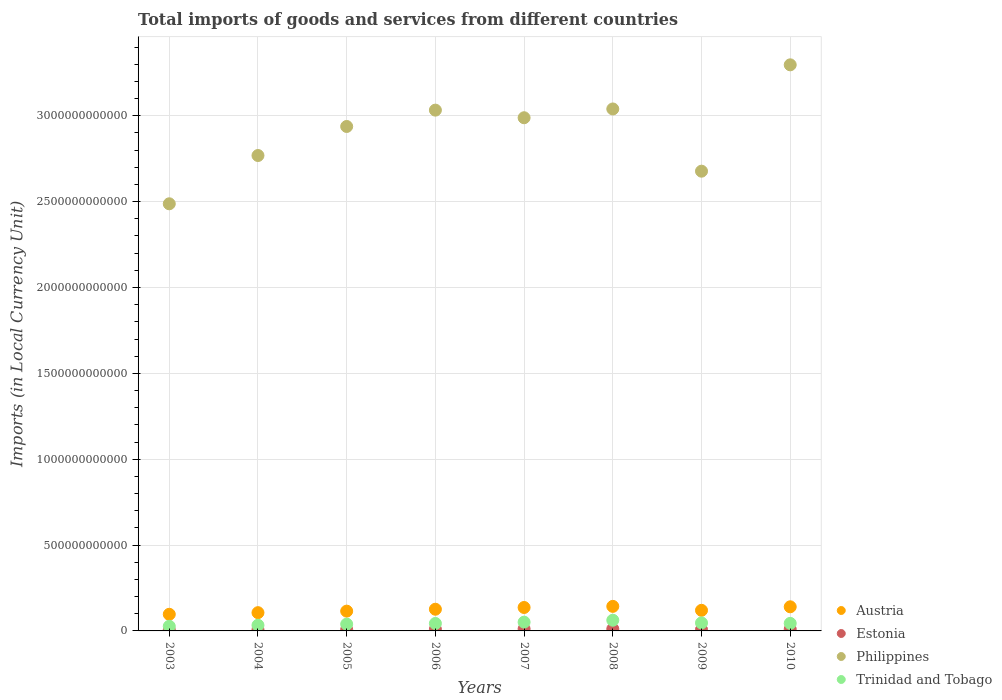How many different coloured dotlines are there?
Your response must be concise. 4. What is the Amount of goods and services imports in Austria in 2005?
Offer a terse response. 1.15e+11. Across all years, what is the maximum Amount of goods and services imports in Estonia?
Give a very brief answer. 1.17e+1. Across all years, what is the minimum Amount of goods and services imports in Philippines?
Your response must be concise. 2.49e+12. What is the total Amount of goods and services imports in Philippines in the graph?
Keep it short and to the point. 2.32e+13. What is the difference between the Amount of goods and services imports in Philippines in 2009 and that in 2010?
Keep it short and to the point. -6.19e+11. What is the difference between the Amount of goods and services imports in Trinidad and Tobago in 2004 and the Amount of goods and services imports in Philippines in 2010?
Give a very brief answer. -3.26e+12. What is the average Amount of goods and services imports in Trinidad and Tobago per year?
Provide a short and direct response. 4.34e+1. In the year 2004, what is the difference between the Amount of goods and services imports in Philippines and Amount of goods and services imports in Trinidad and Tobago?
Offer a terse response. 2.74e+12. What is the ratio of the Amount of goods and services imports in Philippines in 2006 to that in 2009?
Your answer should be very brief. 1.13. Is the Amount of goods and services imports in Estonia in 2004 less than that in 2005?
Make the answer very short. Yes. Is the difference between the Amount of goods and services imports in Philippines in 2003 and 2006 greater than the difference between the Amount of goods and services imports in Trinidad and Tobago in 2003 and 2006?
Offer a terse response. No. What is the difference between the highest and the second highest Amount of goods and services imports in Trinidad and Tobago?
Ensure brevity in your answer.  1.13e+1. What is the difference between the highest and the lowest Amount of goods and services imports in Philippines?
Keep it short and to the point. 8.09e+11. Is the sum of the Amount of goods and services imports in Philippines in 2006 and 2007 greater than the maximum Amount of goods and services imports in Austria across all years?
Give a very brief answer. Yes. How many dotlines are there?
Your answer should be compact. 4. What is the difference between two consecutive major ticks on the Y-axis?
Provide a succinct answer. 5.00e+11. Are the values on the major ticks of Y-axis written in scientific E-notation?
Keep it short and to the point. No. Does the graph contain any zero values?
Offer a very short reply. No. Does the graph contain grids?
Provide a short and direct response. Yes. Where does the legend appear in the graph?
Make the answer very short. Bottom right. How many legend labels are there?
Offer a terse response. 4. What is the title of the graph?
Your answer should be compact. Total imports of goods and services from different countries. Does "San Marino" appear as one of the legend labels in the graph?
Your answer should be very brief. No. What is the label or title of the X-axis?
Your response must be concise. Years. What is the label or title of the Y-axis?
Your response must be concise. Imports (in Local Currency Unit). What is the Imports (in Local Currency Unit) of Austria in 2003?
Your answer should be very brief. 9.68e+1. What is the Imports (in Local Currency Unit) of Estonia in 2003?
Your answer should be very brief. 5.74e+09. What is the Imports (in Local Currency Unit) in Philippines in 2003?
Offer a terse response. 2.49e+12. What is the Imports (in Local Currency Unit) of Trinidad and Tobago in 2003?
Your response must be concise. 2.70e+1. What is the Imports (in Local Currency Unit) of Austria in 2004?
Your answer should be very brief. 1.06e+11. What is the Imports (in Local Currency Unit) in Estonia in 2004?
Your answer should be very brief. 6.74e+09. What is the Imports (in Local Currency Unit) of Philippines in 2004?
Give a very brief answer. 2.77e+12. What is the Imports (in Local Currency Unit) of Trinidad and Tobago in 2004?
Your answer should be very brief. 3.32e+1. What is the Imports (in Local Currency Unit) in Austria in 2005?
Offer a terse response. 1.15e+11. What is the Imports (in Local Currency Unit) of Estonia in 2005?
Provide a short and direct response. 8.00e+09. What is the Imports (in Local Currency Unit) of Philippines in 2005?
Your answer should be very brief. 2.94e+12. What is the Imports (in Local Currency Unit) of Trinidad and Tobago in 2005?
Provide a succinct answer. 3.95e+1. What is the Imports (in Local Currency Unit) in Austria in 2006?
Provide a succinct answer. 1.26e+11. What is the Imports (in Local Currency Unit) in Estonia in 2006?
Keep it short and to the point. 9.96e+09. What is the Imports (in Local Currency Unit) in Philippines in 2006?
Provide a short and direct response. 3.03e+12. What is the Imports (in Local Currency Unit) of Trinidad and Tobago in 2006?
Keep it short and to the point. 4.34e+1. What is the Imports (in Local Currency Unit) of Austria in 2007?
Your response must be concise. 1.36e+11. What is the Imports (in Local Currency Unit) in Estonia in 2007?
Offer a very short reply. 1.17e+1. What is the Imports (in Local Currency Unit) in Philippines in 2007?
Provide a succinct answer. 2.99e+12. What is the Imports (in Local Currency Unit) in Trinidad and Tobago in 2007?
Keep it short and to the point. 5.10e+1. What is the Imports (in Local Currency Unit) in Austria in 2008?
Keep it short and to the point. 1.43e+11. What is the Imports (in Local Currency Unit) in Estonia in 2008?
Ensure brevity in your answer.  1.17e+1. What is the Imports (in Local Currency Unit) in Philippines in 2008?
Give a very brief answer. 3.04e+12. What is the Imports (in Local Currency Unit) of Trinidad and Tobago in 2008?
Give a very brief answer. 6.23e+1. What is the Imports (in Local Currency Unit) in Austria in 2009?
Offer a very short reply. 1.20e+11. What is the Imports (in Local Currency Unit) in Estonia in 2009?
Provide a short and direct response. 7.90e+09. What is the Imports (in Local Currency Unit) in Philippines in 2009?
Provide a short and direct response. 2.68e+12. What is the Imports (in Local Currency Unit) of Trinidad and Tobago in 2009?
Offer a very short reply. 4.66e+1. What is the Imports (in Local Currency Unit) of Austria in 2010?
Offer a very short reply. 1.40e+11. What is the Imports (in Local Currency Unit) of Estonia in 2010?
Keep it short and to the point. 1.01e+1. What is the Imports (in Local Currency Unit) in Philippines in 2010?
Offer a terse response. 3.30e+12. What is the Imports (in Local Currency Unit) of Trinidad and Tobago in 2010?
Provide a succinct answer. 4.39e+1. Across all years, what is the maximum Imports (in Local Currency Unit) in Austria?
Your response must be concise. 1.43e+11. Across all years, what is the maximum Imports (in Local Currency Unit) of Estonia?
Keep it short and to the point. 1.17e+1. Across all years, what is the maximum Imports (in Local Currency Unit) of Philippines?
Your answer should be compact. 3.30e+12. Across all years, what is the maximum Imports (in Local Currency Unit) of Trinidad and Tobago?
Your answer should be compact. 6.23e+1. Across all years, what is the minimum Imports (in Local Currency Unit) of Austria?
Offer a terse response. 9.68e+1. Across all years, what is the minimum Imports (in Local Currency Unit) in Estonia?
Offer a terse response. 5.74e+09. Across all years, what is the minimum Imports (in Local Currency Unit) of Philippines?
Your answer should be very brief. 2.49e+12. Across all years, what is the minimum Imports (in Local Currency Unit) of Trinidad and Tobago?
Your response must be concise. 2.70e+1. What is the total Imports (in Local Currency Unit) of Austria in the graph?
Provide a succinct answer. 9.84e+11. What is the total Imports (in Local Currency Unit) in Estonia in the graph?
Keep it short and to the point. 7.18e+1. What is the total Imports (in Local Currency Unit) of Philippines in the graph?
Your response must be concise. 2.32e+13. What is the total Imports (in Local Currency Unit) in Trinidad and Tobago in the graph?
Provide a short and direct response. 3.47e+11. What is the difference between the Imports (in Local Currency Unit) of Austria in 2003 and that in 2004?
Offer a terse response. -9.49e+09. What is the difference between the Imports (in Local Currency Unit) in Estonia in 2003 and that in 2004?
Offer a very short reply. -9.99e+08. What is the difference between the Imports (in Local Currency Unit) in Philippines in 2003 and that in 2004?
Your answer should be compact. -2.81e+11. What is the difference between the Imports (in Local Currency Unit) in Trinidad and Tobago in 2003 and that in 2004?
Your answer should be compact. -6.20e+09. What is the difference between the Imports (in Local Currency Unit) of Austria in 2003 and that in 2005?
Offer a very short reply. -1.84e+1. What is the difference between the Imports (in Local Currency Unit) in Estonia in 2003 and that in 2005?
Make the answer very short. -2.26e+09. What is the difference between the Imports (in Local Currency Unit) of Philippines in 2003 and that in 2005?
Offer a terse response. -4.50e+11. What is the difference between the Imports (in Local Currency Unit) in Trinidad and Tobago in 2003 and that in 2005?
Offer a very short reply. -1.25e+1. What is the difference between the Imports (in Local Currency Unit) of Austria in 2003 and that in 2006?
Your response must be concise. -2.95e+1. What is the difference between the Imports (in Local Currency Unit) in Estonia in 2003 and that in 2006?
Your answer should be very brief. -4.22e+09. What is the difference between the Imports (in Local Currency Unit) in Philippines in 2003 and that in 2006?
Offer a very short reply. -5.45e+11. What is the difference between the Imports (in Local Currency Unit) of Trinidad and Tobago in 2003 and that in 2006?
Your response must be concise. -1.65e+1. What is the difference between the Imports (in Local Currency Unit) of Austria in 2003 and that in 2007?
Offer a terse response. -3.97e+1. What is the difference between the Imports (in Local Currency Unit) of Estonia in 2003 and that in 2007?
Provide a short and direct response. -5.97e+09. What is the difference between the Imports (in Local Currency Unit) of Philippines in 2003 and that in 2007?
Your response must be concise. -5.01e+11. What is the difference between the Imports (in Local Currency Unit) of Trinidad and Tobago in 2003 and that in 2007?
Ensure brevity in your answer.  -2.41e+1. What is the difference between the Imports (in Local Currency Unit) in Austria in 2003 and that in 2008?
Your response must be concise. -4.61e+1. What is the difference between the Imports (in Local Currency Unit) of Estonia in 2003 and that in 2008?
Ensure brevity in your answer.  -5.94e+09. What is the difference between the Imports (in Local Currency Unit) in Philippines in 2003 and that in 2008?
Your answer should be compact. -5.52e+11. What is the difference between the Imports (in Local Currency Unit) of Trinidad and Tobago in 2003 and that in 2008?
Your response must be concise. -3.53e+1. What is the difference between the Imports (in Local Currency Unit) of Austria in 2003 and that in 2009?
Ensure brevity in your answer.  -2.31e+1. What is the difference between the Imports (in Local Currency Unit) of Estonia in 2003 and that in 2009?
Ensure brevity in your answer.  -2.16e+09. What is the difference between the Imports (in Local Currency Unit) in Philippines in 2003 and that in 2009?
Make the answer very short. -1.90e+11. What is the difference between the Imports (in Local Currency Unit) of Trinidad and Tobago in 2003 and that in 2009?
Keep it short and to the point. -1.96e+1. What is the difference between the Imports (in Local Currency Unit) of Austria in 2003 and that in 2010?
Give a very brief answer. -4.37e+1. What is the difference between the Imports (in Local Currency Unit) of Estonia in 2003 and that in 2010?
Make the answer very short. -4.38e+09. What is the difference between the Imports (in Local Currency Unit) of Philippines in 2003 and that in 2010?
Your response must be concise. -8.09e+11. What is the difference between the Imports (in Local Currency Unit) of Trinidad and Tobago in 2003 and that in 2010?
Provide a short and direct response. -1.70e+1. What is the difference between the Imports (in Local Currency Unit) of Austria in 2004 and that in 2005?
Offer a terse response. -8.89e+09. What is the difference between the Imports (in Local Currency Unit) of Estonia in 2004 and that in 2005?
Provide a succinct answer. -1.26e+09. What is the difference between the Imports (in Local Currency Unit) of Philippines in 2004 and that in 2005?
Offer a terse response. -1.69e+11. What is the difference between the Imports (in Local Currency Unit) of Trinidad and Tobago in 2004 and that in 2005?
Offer a terse response. -6.31e+09. What is the difference between the Imports (in Local Currency Unit) of Austria in 2004 and that in 2006?
Ensure brevity in your answer.  -2.00e+1. What is the difference between the Imports (in Local Currency Unit) in Estonia in 2004 and that in 2006?
Keep it short and to the point. -3.22e+09. What is the difference between the Imports (in Local Currency Unit) of Philippines in 2004 and that in 2006?
Provide a succinct answer. -2.64e+11. What is the difference between the Imports (in Local Currency Unit) of Trinidad and Tobago in 2004 and that in 2006?
Make the answer very short. -1.03e+1. What is the difference between the Imports (in Local Currency Unit) of Austria in 2004 and that in 2007?
Ensure brevity in your answer.  -3.02e+1. What is the difference between the Imports (in Local Currency Unit) of Estonia in 2004 and that in 2007?
Keep it short and to the point. -4.97e+09. What is the difference between the Imports (in Local Currency Unit) in Philippines in 2004 and that in 2007?
Your answer should be very brief. -2.20e+11. What is the difference between the Imports (in Local Currency Unit) of Trinidad and Tobago in 2004 and that in 2007?
Your answer should be very brief. -1.79e+1. What is the difference between the Imports (in Local Currency Unit) in Austria in 2004 and that in 2008?
Keep it short and to the point. -3.67e+1. What is the difference between the Imports (in Local Currency Unit) in Estonia in 2004 and that in 2008?
Your response must be concise. -4.95e+09. What is the difference between the Imports (in Local Currency Unit) in Philippines in 2004 and that in 2008?
Offer a terse response. -2.71e+11. What is the difference between the Imports (in Local Currency Unit) of Trinidad and Tobago in 2004 and that in 2008?
Provide a short and direct response. -2.91e+1. What is the difference between the Imports (in Local Currency Unit) in Austria in 2004 and that in 2009?
Provide a short and direct response. -1.36e+1. What is the difference between the Imports (in Local Currency Unit) of Estonia in 2004 and that in 2009?
Your answer should be compact. -1.16e+09. What is the difference between the Imports (in Local Currency Unit) in Philippines in 2004 and that in 2009?
Keep it short and to the point. 9.12e+1. What is the difference between the Imports (in Local Currency Unit) of Trinidad and Tobago in 2004 and that in 2009?
Ensure brevity in your answer.  -1.34e+1. What is the difference between the Imports (in Local Currency Unit) in Austria in 2004 and that in 2010?
Your answer should be very brief. -3.42e+1. What is the difference between the Imports (in Local Currency Unit) in Estonia in 2004 and that in 2010?
Your answer should be very brief. -3.38e+09. What is the difference between the Imports (in Local Currency Unit) of Philippines in 2004 and that in 2010?
Make the answer very short. -5.28e+11. What is the difference between the Imports (in Local Currency Unit) of Trinidad and Tobago in 2004 and that in 2010?
Provide a short and direct response. -1.08e+1. What is the difference between the Imports (in Local Currency Unit) in Austria in 2005 and that in 2006?
Provide a succinct answer. -1.11e+1. What is the difference between the Imports (in Local Currency Unit) in Estonia in 2005 and that in 2006?
Your response must be concise. -1.96e+09. What is the difference between the Imports (in Local Currency Unit) of Philippines in 2005 and that in 2006?
Your response must be concise. -9.51e+1. What is the difference between the Imports (in Local Currency Unit) of Trinidad and Tobago in 2005 and that in 2006?
Give a very brief answer. -3.96e+09. What is the difference between the Imports (in Local Currency Unit) in Austria in 2005 and that in 2007?
Ensure brevity in your answer.  -2.13e+1. What is the difference between the Imports (in Local Currency Unit) of Estonia in 2005 and that in 2007?
Your answer should be very brief. -3.71e+09. What is the difference between the Imports (in Local Currency Unit) in Philippines in 2005 and that in 2007?
Provide a short and direct response. -5.08e+1. What is the difference between the Imports (in Local Currency Unit) of Trinidad and Tobago in 2005 and that in 2007?
Your answer should be compact. -1.16e+1. What is the difference between the Imports (in Local Currency Unit) of Austria in 2005 and that in 2008?
Give a very brief answer. -2.78e+1. What is the difference between the Imports (in Local Currency Unit) in Estonia in 2005 and that in 2008?
Your answer should be very brief. -3.68e+09. What is the difference between the Imports (in Local Currency Unit) of Philippines in 2005 and that in 2008?
Provide a succinct answer. -1.02e+11. What is the difference between the Imports (in Local Currency Unit) in Trinidad and Tobago in 2005 and that in 2008?
Keep it short and to the point. -2.28e+1. What is the difference between the Imports (in Local Currency Unit) of Austria in 2005 and that in 2009?
Offer a terse response. -4.75e+09. What is the difference between the Imports (in Local Currency Unit) in Estonia in 2005 and that in 2009?
Provide a short and direct response. 9.77e+07. What is the difference between the Imports (in Local Currency Unit) in Philippines in 2005 and that in 2009?
Make the answer very short. 2.60e+11. What is the difference between the Imports (in Local Currency Unit) in Trinidad and Tobago in 2005 and that in 2009?
Give a very brief answer. -7.10e+09. What is the difference between the Imports (in Local Currency Unit) of Austria in 2005 and that in 2010?
Make the answer very short. -2.53e+1. What is the difference between the Imports (in Local Currency Unit) of Estonia in 2005 and that in 2010?
Provide a short and direct response. -2.12e+09. What is the difference between the Imports (in Local Currency Unit) in Philippines in 2005 and that in 2010?
Make the answer very short. -3.59e+11. What is the difference between the Imports (in Local Currency Unit) in Trinidad and Tobago in 2005 and that in 2010?
Your answer should be compact. -4.46e+09. What is the difference between the Imports (in Local Currency Unit) in Austria in 2006 and that in 2007?
Your answer should be very brief. -1.02e+1. What is the difference between the Imports (in Local Currency Unit) in Estonia in 2006 and that in 2007?
Offer a very short reply. -1.75e+09. What is the difference between the Imports (in Local Currency Unit) in Philippines in 2006 and that in 2007?
Offer a very short reply. 4.43e+1. What is the difference between the Imports (in Local Currency Unit) in Trinidad and Tobago in 2006 and that in 2007?
Your response must be concise. -7.60e+09. What is the difference between the Imports (in Local Currency Unit) of Austria in 2006 and that in 2008?
Offer a terse response. -1.67e+1. What is the difference between the Imports (in Local Currency Unit) of Estonia in 2006 and that in 2008?
Ensure brevity in your answer.  -1.73e+09. What is the difference between the Imports (in Local Currency Unit) of Philippines in 2006 and that in 2008?
Your answer should be compact. -6.83e+09. What is the difference between the Imports (in Local Currency Unit) in Trinidad and Tobago in 2006 and that in 2008?
Give a very brief answer. -1.89e+1. What is the difference between the Imports (in Local Currency Unit) of Austria in 2006 and that in 2009?
Keep it short and to the point. 6.36e+09. What is the difference between the Imports (in Local Currency Unit) of Estonia in 2006 and that in 2009?
Provide a short and direct response. 2.06e+09. What is the difference between the Imports (in Local Currency Unit) in Philippines in 2006 and that in 2009?
Your answer should be compact. 3.56e+11. What is the difference between the Imports (in Local Currency Unit) in Trinidad and Tobago in 2006 and that in 2009?
Your answer should be very brief. -3.14e+09. What is the difference between the Imports (in Local Currency Unit) in Austria in 2006 and that in 2010?
Offer a very short reply. -1.42e+1. What is the difference between the Imports (in Local Currency Unit) in Estonia in 2006 and that in 2010?
Give a very brief answer. -1.57e+08. What is the difference between the Imports (in Local Currency Unit) in Philippines in 2006 and that in 2010?
Offer a terse response. -2.64e+11. What is the difference between the Imports (in Local Currency Unit) in Trinidad and Tobago in 2006 and that in 2010?
Ensure brevity in your answer.  -5.01e+08. What is the difference between the Imports (in Local Currency Unit) in Austria in 2007 and that in 2008?
Provide a short and direct response. -6.49e+09. What is the difference between the Imports (in Local Currency Unit) of Estonia in 2007 and that in 2008?
Your answer should be compact. 2.69e+07. What is the difference between the Imports (in Local Currency Unit) of Philippines in 2007 and that in 2008?
Ensure brevity in your answer.  -5.11e+1. What is the difference between the Imports (in Local Currency Unit) in Trinidad and Tobago in 2007 and that in 2008?
Keep it short and to the point. -1.13e+1. What is the difference between the Imports (in Local Currency Unit) of Austria in 2007 and that in 2009?
Your response must be concise. 1.65e+1. What is the difference between the Imports (in Local Currency Unit) of Estonia in 2007 and that in 2009?
Make the answer very short. 3.81e+09. What is the difference between the Imports (in Local Currency Unit) of Philippines in 2007 and that in 2009?
Give a very brief answer. 3.11e+11. What is the difference between the Imports (in Local Currency Unit) of Trinidad and Tobago in 2007 and that in 2009?
Provide a short and direct response. 4.46e+09. What is the difference between the Imports (in Local Currency Unit) of Austria in 2007 and that in 2010?
Your answer should be very brief. -4.01e+09. What is the difference between the Imports (in Local Currency Unit) in Estonia in 2007 and that in 2010?
Offer a terse response. 1.60e+09. What is the difference between the Imports (in Local Currency Unit) of Philippines in 2007 and that in 2010?
Offer a very short reply. -3.08e+11. What is the difference between the Imports (in Local Currency Unit) in Trinidad and Tobago in 2007 and that in 2010?
Your answer should be very brief. 7.10e+09. What is the difference between the Imports (in Local Currency Unit) in Austria in 2008 and that in 2009?
Give a very brief answer. 2.30e+1. What is the difference between the Imports (in Local Currency Unit) in Estonia in 2008 and that in 2009?
Provide a succinct answer. 3.78e+09. What is the difference between the Imports (in Local Currency Unit) of Philippines in 2008 and that in 2009?
Your answer should be compact. 3.62e+11. What is the difference between the Imports (in Local Currency Unit) in Trinidad and Tobago in 2008 and that in 2009?
Provide a succinct answer. 1.57e+1. What is the difference between the Imports (in Local Currency Unit) in Austria in 2008 and that in 2010?
Your response must be concise. 2.48e+09. What is the difference between the Imports (in Local Currency Unit) of Estonia in 2008 and that in 2010?
Give a very brief answer. 1.57e+09. What is the difference between the Imports (in Local Currency Unit) in Philippines in 2008 and that in 2010?
Your answer should be compact. -2.57e+11. What is the difference between the Imports (in Local Currency Unit) in Trinidad and Tobago in 2008 and that in 2010?
Keep it short and to the point. 1.84e+1. What is the difference between the Imports (in Local Currency Unit) in Austria in 2009 and that in 2010?
Your answer should be very brief. -2.05e+1. What is the difference between the Imports (in Local Currency Unit) in Estonia in 2009 and that in 2010?
Offer a very short reply. -2.21e+09. What is the difference between the Imports (in Local Currency Unit) of Philippines in 2009 and that in 2010?
Make the answer very short. -6.19e+11. What is the difference between the Imports (in Local Currency Unit) in Trinidad and Tobago in 2009 and that in 2010?
Provide a short and direct response. 2.64e+09. What is the difference between the Imports (in Local Currency Unit) in Austria in 2003 and the Imports (in Local Currency Unit) in Estonia in 2004?
Ensure brevity in your answer.  9.01e+1. What is the difference between the Imports (in Local Currency Unit) of Austria in 2003 and the Imports (in Local Currency Unit) of Philippines in 2004?
Your answer should be very brief. -2.67e+12. What is the difference between the Imports (in Local Currency Unit) of Austria in 2003 and the Imports (in Local Currency Unit) of Trinidad and Tobago in 2004?
Your answer should be compact. 6.37e+1. What is the difference between the Imports (in Local Currency Unit) in Estonia in 2003 and the Imports (in Local Currency Unit) in Philippines in 2004?
Make the answer very short. -2.76e+12. What is the difference between the Imports (in Local Currency Unit) of Estonia in 2003 and the Imports (in Local Currency Unit) of Trinidad and Tobago in 2004?
Your answer should be compact. -2.74e+1. What is the difference between the Imports (in Local Currency Unit) of Philippines in 2003 and the Imports (in Local Currency Unit) of Trinidad and Tobago in 2004?
Offer a very short reply. 2.45e+12. What is the difference between the Imports (in Local Currency Unit) of Austria in 2003 and the Imports (in Local Currency Unit) of Estonia in 2005?
Offer a very short reply. 8.88e+1. What is the difference between the Imports (in Local Currency Unit) in Austria in 2003 and the Imports (in Local Currency Unit) in Philippines in 2005?
Your answer should be very brief. -2.84e+12. What is the difference between the Imports (in Local Currency Unit) in Austria in 2003 and the Imports (in Local Currency Unit) in Trinidad and Tobago in 2005?
Your answer should be compact. 5.73e+1. What is the difference between the Imports (in Local Currency Unit) in Estonia in 2003 and the Imports (in Local Currency Unit) in Philippines in 2005?
Provide a succinct answer. -2.93e+12. What is the difference between the Imports (in Local Currency Unit) in Estonia in 2003 and the Imports (in Local Currency Unit) in Trinidad and Tobago in 2005?
Make the answer very short. -3.37e+1. What is the difference between the Imports (in Local Currency Unit) in Philippines in 2003 and the Imports (in Local Currency Unit) in Trinidad and Tobago in 2005?
Your answer should be very brief. 2.45e+12. What is the difference between the Imports (in Local Currency Unit) of Austria in 2003 and the Imports (in Local Currency Unit) of Estonia in 2006?
Your answer should be compact. 8.69e+1. What is the difference between the Imports (in Local Currency Unit) in Austria in 2003 and the Imports (in Local Currency Unit) in Philippines in 2006?
Ensure brevity in your answer.  -2.94e+12. What is the difference between the Imports (in Local Currency Unit) of Austria in 2003 and the Imports (in Local Currency Unit) of Trinidad and Tobago in 2006?
Offer a terse response. 5.34e+1. What is the difference between the Imports (in Local Currency Unit) of Estonia in 2003 and the Imports (in Local Currency Unit) of Philippines in 2006?
Ensure brevity in your answer.  -3.03e+12. What is the difference between the Imports (in Local Currency Unit) of Estonia in 2003 and the Imports (in Local Currency Unit) of Trinidad and Tobago in 2006?
Your answer should be very brief. -3.77e+1. What is the difference between the Imports (in Local Currency Unit) of Philippines in 2003 and the Imports (in Local Currency Unit) of Trinidad and Tobago in 2006?
Keep it short and to the point. 2.44e+12. What is the difference between the Imports (in Local Currency Unit) in Austria in 2003 and the Imports (in Local Currency Unit) in Estonia in 2007?
Give a very brief answer. 8.51e+1. What is the difference between the Imports (in Local Currency Unit) of Austria in 2003 and the Imports (in Local Currency Unit) of Philippines in 2007?
Offer a very short reply. -2.89e+12. What is the difference between the Imports (in Local Currency Unit) of Austria in 2003 and the Imports (in Local Currency Unit) of Trinidad and Tobago in 2007?
Ensure brevity in your answer.  4.58e+1. What is the difference between the Imports (in Local Currency Unit) of Estonia in 2003 and the Imports (in Local Currency Unit) of Philippines in 2007?
Keep it short and to the point. -2.98e+12. What is the difference between the Imports (in Local Currency Unit) of Estonia in 2003 and the Imports (in Local Currency Unit) of Trinidad and Tobago in 2007?
Provide a short and direct response. -4.53e+1. What is the difference between the Imports (in Local Currency Unit) of Philippines in 2003 and the Imports (in Local Currency Unit) of Trinidad and Tobago in 2007?
Ensure brevity in your answer.  2.44e+12. What is the difference between the Imports (in Local Currency Unit) of Austria in 2003 and the Imports (in Local Currency Unit) of Estonia in 2008?
Offer a terse response. 8.51e+1. What is the difference between the Imports (in Local Currency Unit) of Austria in 2003 and the Imports (in Local Currency Unit) of Philippines in 2008?
Keep it short and to the point. -2.94e+12. What is the difference between the Imports (in Local Currency Unit) of Austria in 2003 and the Imports (in Local Currency Unit) of Trinidad and Tobago in 2008?
Offer a very short reply. 3.45e+1. What is the difference between the Imports (in Local Currency Unit) of Estonia in 2003 and the Imports (in Local Currency Unit) of Philippines in 2008?
Your answer should be very brief. -3.03e+12. What is the difference between the Imports (in Local Currency Unit) in Estonia in 2003 and the Imports (in Local Currency Unit) in Trinidad and Tobago in 2008?
Your answer should be very brief. -5.65e+1. What is the difference between the Imports (in Local Currency Unit) of Philippines in 2003 and the Imports (in Local Currency Unit) of Trinidad and Tobago in 2008?
Give a very brief answer. 2.43e+12. What is the difference between the Imports (in Local Currency Unit) in Austria in 2003 and the Imports (in Local Currency Unit) in Estonia in 2009?
Ensure brevity in your answer.  8.89e+1. What is the difference between the Imports (in Local Currency Unit) of Austria in 2003 and the Imports (in Local Currency Unit) of Philippines in 2009?
Provide a short and direct response. -2.58e+12. What is the difference between the Imports (in Local Currency Unit) of Austria in 2003 and the Imports (in Local Currency Unit) of Trinidad and Tobago in 2009?
Give a very brief answer. 5.02e+1. What is the difference between the Imports (in Local Currency Unit) of Estonia in 2003 and the Imports (in Local Currency Unit) of Philippines in 2009?
Offer a very short reply. -2.67e+12. What is the difference between the Imports (in Local Currency Unit) of Estonia in 2003 and the Imports (in Local Currency Unit) of Trinidad and Tobago in 2009?
Ensure brevity in your answer.  -4.08e+1. What is the difference between the Imports (in Local Currency Unit) in Philippines in 2003 and the Imports (in Local Currency Unit) in Trinidad and Tobago in 2009?
Offer a very short reply. 2.44e+12. What is the difference between the Imports (in Local Currency Unit) in Austria in 2003 and the Imports (in Local Currency Unit) in Estonia in 2010?
Offer a terse response. 8.67e+1. What is the difference between the Imports (in Local Currency Unit) of Austria in 2003 and the Imports (in Local Currency Unit) of Philippines in 2010?
Offer a terse response. -3.20e+12. What is the difference between the Imports (in Local Currency Unit) in Austria in 2003 and the Imports (in Local Currency Unit) in Trinidad and Tobago in 2010?
Provide a succinct answer. 5.29e+1. What is the difference between the Imports (in Local Currency Unit) in Estonia in 2003 and the Imports (in Local Currency Unit) in Philippines in 2010?
Your answer should be very brief. -3.29e+12. What is the difference between the Imports (in Local Currency Unit) of Estonia in 2003 and the Imports (in Local Currency Unit) of Trinidad and Tobago in 2010?
Provide a short and direct response. -3.82e+1. What is the difference between the Imports (in Local Currency Unit) in Philippines in 2003 and the Imports (in Local Currency Unit) in Trinidad and Tobago in 2010?
Ensure brevity in your answer.  2.44e+12. What is the difference between the Imports (in Local Currency Unit) of Austria in 2004 and the Imports (in Local Currency Unit) of Estonia in 2005?
Offer a terse response. 9.83e+1. What is the difference between the Imports (in Local Currency Unit) of Austria in 2004 and the Imports (in Local Currency Unit) of Philippines in 2005?
Your answer should be compact. -2.83e+12. What is the difference between the Imports (in Local Currency Unit) in Austria in 2004 and the Imports (in Local Currency Unit) in Trinidad and Tobago in 2005?
Your answer should be compact. 6.68e+1. What is the difference between the Imports (in Local Currency Unit) of Estonia in 2004 and the Imports (in Local Currency Unit) of Philippines in 2005?
Provide a succinct answer. -2.93e+12. What is the difference between the Imports (in Local Currency Unit) in Estonia in 2004 and the Imports (in Local Currency Unit) in Trinidad and Tobago in 2005?
Make the answer very short. -3.27e+1. What is the difference between the Imports (in Local Currency Unit) of Philippines in 2004 and the Imports (in Local Currency Unit) of Trinidad and Tobago in 2005?
Your answer should be compact. 2.73e+12. What is the difference between the Imports (in Local Currency Unit) of Austria in 2004 and the Imports (in Local Currency Unit) of Estonia in 2006?
Your answer should be compact. 9.63e+1. What is the difference between the Imports (in Local Currency Unit) in Austria in 2004 and the Imports (in Local Currency Unit) in Philippines in 2006?
Your response must be concise. -2.93e+12. What is the difference between the Imports (in Local Currency Unit) in Austria in 2004 and the Imports (in Local Currency Unit) in Trinidad and Tobago in 2006?
Offer a very short reply. 6.29e+1. What is the difference between the Imports (in Local Currency Unit) in Estonia in 2004 and the Imports (in Local Currency Unit) in Philippines in 2006?
Provide a short and direct response. -3.03e+12. What is the difference between the Imports (in Local Currency Unit) in Estonia in 2004 and the Imports (in Local Currency Unit) in Trinidad and Tobago in 2006?
Provide a short and direct response. -3.67e+1. What is the difference between the Imports (in Local Currency Unit) in Philippines in 2004 and the Imports (in Local Currency Unit) in Trinidad and Tobago in 2006?
Provide a short and direct response. 2.73e+12. What is the difference between the Imports (in Local Currency Unit) in Austria in 2004 and the Imports (in Local Currency Unit) in Estonia in 2007?
Keep it short and to the point. 9.46e+1. What is the difference between the Imports (in Local Currency Unit) of Austria in 2004 and the Imports (in Local Currency Unit) of Philippines in 2007?
Ensure brevity in your answer.  -2.88e+12. What is the difference between the Imports (in Local Currency Unit) of Austria in 2004 and the Imports (in Local Currency Unit) of Trinidad and Tobago in 2007?
Your response must be concise. 5.53e+1. What is the difference between the Imports (in Local Currency Unit) of Estonia in 2004 and the Imports (in Local Currency Unit) of Philippines in 2007?
Provide a succinct answer. -2.98e+12. What is the difference between the Imports (in Local Currency Unit) of Estonia in 2004 and the Imports (in Local Currency Unit) of Trinidad and Tobago in 2007?
Give a very brief answer. -4.43e+1. What is the difference between the Imports (in Local Currency Unit) of Philippines in 2004 and the Imports (in Local Currency Unit) of Trinidad and Tobago in 2007?
Ensure brevity in your answer.  2.72e+12. What is the difference between the Imports (in Local Currency Unit) in Austria in 2004 and the Imports (in Local Currency Unit) in Estonia in 2008?
Your response must be concise. 9.46e+1. What is the difference between the Imports (in Local Currency Unit) in Austria in 2004 and the Imports (in Local Currency Unit) in Philippines in 2008?
Provide a short and direct response. -2.93e+12. What is the difference between the Imports (in Local Currency Unit) in Austria in 2004 and the Imports (in Local Currency Unit) in Trinidad and Tobago in 2008?
Provide a succinct answer. 4.40e+1. What is the difference between the Imports (in Local Currency Unit) of Estonia in 2004 and the Imports (in Local Currency Unit) of Philippines in 2008?
Your answer should be compact. -3.03e+12. What is the difference between the Imports (in Local Currency Unit) in Estonia in 2004 and the Imports (in Local Currency Unit) in Trinidad and Tobago in 2008?
Keep it short and to the point. -5.55e+1. What is the difference between the Imports (in Local Currency Unit) in Philippines in 2004 and the Imports (in Local Currency Unit) in Trinidad and Tobago in 2008?
Keep it short and to the point. 2.71e+12. What is the difference between the Imports (in Local Currency Unit) of Austria in 2004 and the Imports (in Local Currency Unit) of Estonia in 2009?
Provide a short and direct response. 9.84e+1. What is the difference between the Imports (in Local Currency Unit) in Austria in 2004 and the Imports (in Local Currency Unit) in Philippines in 2009?
Offer a terse response. -2.57e+12. What is the difference between the Imports (in Local Currency Unit) in Austria in 2004 and the Imports (in Local Currency Unit) in Trinidad and Tobago in 2009?
Offer a terse response. 5.97e+1. What is the difference between the Imports (in Local Currency Unit) in Estonia in 2004 and the Imports (in Local Currency Unit) in Philippines in 2009?
Offer a terse response. -2.67e+12. What is the difference between the Imports (in Local Currency Unit) in Estonia in 2004 and the Imports (in Local Currency Unit) in Trinidad and Tobago in 2009?
Your response must be concise. -3.98e+1. What is the difference between the Imports (in Local Currency Unit) of Philippines in 2004 and the Imports (in Local Currency Unit) of Trinidad and Tobago in 2009?
Offer a terse response. 2.72e+12. What is the difference between the Imports (in Local Currency Unit) of Austria in 2004 and the Imports (in Local Currency Unit) of Estonia in 2010?
Give a very brief answer. 9.62e+1. What is the difference between the Imports (in Local Currency Unit) of Austria in 2004 and the Imports (in Local Currency Unit) of Philippines in 2010?
Your answer should be very brief. -3.19e+12. What is the difference between the Imports (in Local Currency Unit) in Austria in 2004 and the Imports (in Local Currency Unit) in Trinidad and Tobago in 2010?
Your answer should be very brief. 6.24e+1. What is the difference between the Imports (in Local Currency Unit) of Estonia in 2004 and the Imports (in Local Currency Unit) of Philippines in 2010?
Make the answer very short. -3.29e+12. What is the difference between the Imports (in Local Currency Unit) of Estonia in 2004 and the Imports (in Local Currency Unit) of Trinidad and Tobago in 2010?
Your answer should be compact. -3.72e+1. What is the difference between the Imports (in Local Currency Unit) in Philippines in 2004 and the Imports (in Local Currency Unit) in Trinidad and Tobago in 2010?
Make the answer very short. 2.72e+12. What is the difference between the Imports (in Local Currency Unit) of Austria in 2005 and the Imports (in Local Currency Unit) of Estonia in 2006?
Make the answer very short. 1.05e+11. What is the difference between the Imports (in Local Currency Unit) in Austria in 2005 and the Imports (in Local Currency Unit) in Philippines in 2006?
Offer a terse response. -2.92e+12. What is the difference between the Imports (in Local Currency Unit) of Austria in 2005 and the Imports (in Local Currency Unit) of Trinidad and Tobago in 2006?
Your answer should be compact. 7.18e+1. What is the difference between the Imports (in Local Currency Unit) in Estonia in 2005 and the Imports (in Local Currency Unit) in Philippines in 2006?
Your answer should be very brief. -3.02e+12. What is the difference between the Imports (in Local Currency Unit) of Estonia in 2005 and the Imports (in Local Currency Unit) of Trinidad and Tobago in 2006?
Your response must be concise. -3.54e+1. What is the difference between the Imports (in Local Currency Unit) in Philippines in 2005 and the Imports (in Local Currency Unit) in Trinidad and Tobago in 2006?
Your answer should be very brief. 2.89e+12. What is the difference between the Imports (in Local Currency Unit) of Austria in 2005 and the Imports (in Local Currency Unit) of Estonia in 2007?
Provide a short and direct response. 1.03e+11. What is the difference between the Imports (in Local Currency Unit) in Austria in 2005 and the Imports (in Local Currency Unit) in Philippines in 2007?
Provide a short and direct response. -2.87e+12. What is the difference between the Imports (in Local Currency Unit) of Austria in 2005 and the Imports (in Local Currency Unit) of Trinidad and Tobago in 2007?
Keep it short and to the point. 6.42e+1. What is the difference between the Imports (in Local Currency Unit) of Estonia in 2005 and the Imports (in Local Currency Unit) of Philippines in 2007?
Offer a terse response. -2.98e+12. What is the difference between the Imports (in Local Currency Unit) of Estonia in 2005 and the Imports (in Local Currency Unit) of Trinidad and Tobago in 2007?
Offer a terse response. -4.30e+1. What is the difference between the Imports (in Local Currency Unit) of Philippines in 2005 and the Imports (in Local Currency Unit) of Trinidad and Tobago in 2007?
Provide a succinct answer. 2.89e+12. What is the difference between the Imports (in Local Currency Unit) of Austria in 2005 and the Imports (in Local Currency Unit) of Estonia in 2008?
Provide a succinct answer. 1.04e+11. What is the difference between the Imports (in Local Currency Unit) of Austria in 2005 and the Imports (in Local Currency Unit) of Philippines in 2008?
Ensure brevity in your answer.  -2.92e+12. What is the difference between the Imports (in Local Currency Unit) of Austria in 2005 and the Imports (in Local Currency Unit) of Trinidad and Tobago in 2008?
Offer a terse response. 5.29e+1. What is the difference between the Imports (in Local Currency Unit) of Estonia in 2005 and the Imports (in Local Currency Unit) of Philippines in 2008?
Keep it short and to the point. -3.03e+12. What is the difference between the Imports (in Local Currency Unit) in Estonia in 2005 and the Imports (in Local Currency Unit) in Trinidad and Tobago in 2008?
Your answer should be compact. -5.43e+1. What is the difference between the Imports (in Local Currency Unit) of Philippines in 2005 and the Imports (in Local Currency Unit) of Trinidad and Tobago in 2008?
Your response must be concise. 2.88e+12. What is the difference between the Imports (in Local Currency Unit) of Austria in 2005 and the Imports (in Local Currency Unit) of Estonia in 2009?
Your answer should be compact. 1.07e+11. What is the difference between the Imports (in Local Currency Unit) in Austria in 2005 and the Imports (in Local Currency Unit) in Philippines in 2009?
Your answer should be compact. -2.56e+12. What is the difference between the Imports (in Local Currency Unit) of Austria in 2005 and the Imports (in Local Currency Unit) of Trinidad and Tobago in 2009?
Your response must be concise. 6.86e+1. What is the difference between the Imports (in Local Currency Unit) in Estonia in 2005 and the Imports (in Local Currency Unit) in Philippines in 2009?
Provide a succinct answer. -2.67e+12. What is the difference between the Imports (in Local Currency Unit) in Estonia in 2005 and the Imports (in Local Currency Unit) in Trinidad and Tobago in 2009?
Give a very brief answer. -3.86e+1. What is the difference between the Imports (in Local Currency Unit) of Philippines in 2005 and the Imports (in Local Currency Unit) of Trinidad and Tobago in 2009?
Offer a very short reply. 2.89e+12. What is the difference between the Imports (in Local Currency Unit) of Austria in 2005 and the Imports (in Local Currency Unit) of Estonia in 2010?
Your response must be concise. 1.05e+11. What is the difference between the Imports (in Local Currency Unit) of Austria in 2005 and the Imports (in Local Currency Unit) of Philippines in 2010?
Your response must be concise. -3.18e+12. What is the difference between the Imports (in Local Currency Unit) in Austria in 2005 and the Imports (in Local Currency Unit) in Trinidad and Tobago in 2010?
Provide a short and direct response. 7.13e+1. What is the difference between the Imports (in Local Currency Unit) of Estonia in 2005 and the Imports (in Local Currency Unit) of Philippines in 2010?
Make the answer very short. -3.29e+12. What is the difference between the Imports (in Local Currency Unit) in Estonia in 2005 and the Imports (in Local Currency Unit) in Trinidad and Tobago in 2010?
Give a very brief answer. -3.59e+1. What is the difference between the Imports (in Local Currency Unit) in Philippines in 2005 and the Imports (in Local Currency Unit) in Trinidad and Tobago in 2010?
Your answer should be compact. 2.89e+12. What is the difference between the Imports (in Local Currency Unit) in Austria in 2006 and the Imports (in Local Currency Unit) in Estonia in 2007?
Your answer should be very brief. 1.15e+11. What is the difference between the Imports (in Local Currency Unit) in Austria in 2006 and the Imports (in Local Currency Unit) in Philippines in 2007?
Your answer should be very brief. -2.86e+12. What is the difference between the Imports (in Local Currency Unit) in Austria in 2006 and the Imports (in Local Currency Unit) in Trinidad and Tobago in 2007?
Give a very brief answer. 7.53e+1. What is the difference between the Imports (in Local Currency Unit) of Estonia in 2006 and the Imports (in Local Currency Unit) of Philippines in 2007?
Give a very brief answer. -2.98e+12. What is the difference between the Imports (in Local Currency Unit) in Estonia in 2006 and the Imports (in Local Currency Unit) in Trinidad and Tobago in 2007?
Provide a succinct answer. -4.11e+1. What is the difference between the Imports (in Local Currency Unit) in Philippines in 2006 and the Imports (in Local Currency Unit) in Trinidad and Tobago in 2007?
Provide a short and direct response. 2.98e+12. What is the difference between the Imports (in Local Currency Unit) in Austria in 2006 and the Imports (in Local Currency Unit) in Estonia in 2008?
Ensure brevity in your answer.  1.15e+11. What is the difference between the Imports (in Local Currency Unit) of Austria in 2006 and the Imports (in Local Currency Unit) of Philippines in 2008?
Your response must be concise. -2.91e+12. What is the difference between the Imports (in Local Currency Unit) of Austria in 2006 and the Imports (in Local Currency Unit) of Trinidad and Tobago in 2008?
Ensure brevity in your answer.  6.40e+1. What is the difference between the Imports (in Local Currency Unit) in Estonia in 2006 and the Imports (in Local Currency Unit) in Philippines in 2008?
Keep it short and to the point. -3.03e+12. What is the difference between the Imports (in Local Currency Unit) of Estonia in 2006 and the Imports (in Local Currency Unit) of Trinidad and Tobago in 2008?
Your response must be concise. -5.23e+1. What is the difference between the Imports (in Local Currency Unit) in Philippines in 2006 and the Imports (in Local Currency Unit) in Trinidad and Tobago in 2008?
Give a very brief answer. 2.97e+12. What is the difference between the Imports (in Local Currency Unit) of Austria in 2006 and the Imports (in Local Currency Unit) of Estonia in 2009?
Your answer should be very brief. 1.18e+11. What is the difference between the Imports (in Local Currency Unit) in Austria in 2006 and the Imports (in Local Currency Unit) in Philippines in 2009?
Make the answer very short. -2.55e+12. What is the difference between the Imports (in Local Currency Unit) of Austria in 2006 and the Imports (in Local Currency Unit) of Trinidad and Tobago in 2009?
Give a very brief answer. 7.97e+1. What is the difference between the Imports (in Local Currency Unit) of Estonia in 2006 and the Imports (in Local Currency Unit) of Philippines in 2009?
Keep it short and to the point. -2.67e+12. What is the difference between the Imports (in Local Currency Unit) in Estonia in 2006 and the Imports (in Local Currency Unit) in Trinidad and Tobago in 2009?
Offer a terse response. -3.66e+1. What is the difference between the Imports (in Local Currency Unit) of Philippines in 2006 and the Imports (in Local Currency Unit) of Trinidad and Tobago in 2009?
Ensure brevity in your answer.  2.99e+12. What is the difference between the Imports (in Local Currency Unit) of Austria in 2006 and the Imports (in Local Currency Unit) of Estonia in 2010?
Give a very brief answer. 1.16e+11. What is the difference between the Imports (in Local Currency Unit) of Austria in 2006 and the Imports (in Local Currency Unit) of Philippines in 2010?
Keep it short and to the point. -3.17e+12. What is the difference between the Imports (in Local Currency Unit) of Austria in 2006 and the Imports (in Local Currency Unit) of Trinidad and Tobago in 2010?
Keep it short and to the point. 8.24e+1. What is the difference between the Imports (in Local Currency Unit) in Estonia in 2006 and the Imports (in Local Currency Unit) in Philippines in 2010?
Your answer should be compact. -3.29e+12. What is the difference between the Imports (in Local Currency Unit) of Estonia in 2006 and the Imports (in Local Currency Unit) of Trinidad and Tobago in 2010?
Give a very brief answer. -3.40e+1. What is the difference between the Imports (in Local Currency Unit) of Philippines in 2006 and the Imports (in Local Currency Unit) of Trinidad and Tobago in 2010?
Keep it short and to the point. 2.99e+12. What is the difference between the Imports (in Local Currency Unit) in Austria in 2007 and the Imports (in Local Currency Unit) in Estonia in 2008?
Make the answer very short. 1.25e+11. What is the difference between the Imports (in Local Currency Unit) of Austria in 2007 and the Imports (in Local Currency Unit) of Philippines in 2008?
Offer a terse response. -2.90e+12. What is the difference between the Imports (in Local Currency Unit) in Austria in 2007 and the Imports (in Local Currency Unit) in Trinidad and Tobago in 2008?
Offer a very short reply. 7.42e+1. What is the difference between the Imports (in Local Currency Unit) of Estonia in 2007 and the Imports (in Local Currency Unit) of Philippines in 2008?
Your response must be concise. -3.03e+12. What is the difference between the Imports (in Local Currency Unit) in Estonia in 2007 and the Imports (in Local Currency Unit) in Trinidad and Tobago in 2008?
Provide a succinct answer. -5.06e+1. What is the difference between the Imports (in Local Currency Unit) in Philippines in 2007 and the Imports (in Local Currency Unit) in Trinidad and Tobago in 2008?
Provide a short and direct response. 2.93e+12. What is the difference between the Imports (in Local Currency Unit) of Austria in 2007 and the Imports (in Local Currency Unit) of Estonia in 2009?
Your answer should be very brief. 1.29e+11. What is the difference between the Imports (in Local Currency Unit) in Austria in 2007 and the Imports (in Local Currency Unit) in Philippines in 2009?
Make the answer very short. -2.54e+12. What is the difference between the Imports (in Local Currency Unit) in Austria in 2007 and the Imports (in Local Currency Unit) in Trinidad and Tobago in 2009?
Provide a succinct answer. 8.99e+1. What is the difference between the Imports (in Local Currency Unit) of Estonia in 2007 and the Imports (in Local Currency Unit) of Philippines in 2009?
Provide a succinct answer. -2.67e+12. What is the difference between the Imports (in Local Currency Unit) of Estonia in 2007 and the Imports (in Local Currency Unit) of Trinidad and Tobago in 2009?
Ensure brevity in your answer.  -3.49e+1. What is the difference between the Imports (in Local Currency Unit) in Philippines in 2007 and the Imports (in Local Currency Unit) in Trinidad and Tobago in 2009?
Provide a short and direct response. 2.94e+12. What is the difference between the Imports (in Local Currency Unit) of Austria in 2007 and the Imports (in Local Currency Unit) of Estonia in 2010?
Make the answer very short. 1.26e+11. What is the difference between the Imports (in Local Currency Unit) in Austria in 2007 and the Imports (in Local Currency Unit) in Philippines in 2010?
Your response must be concise. -3.16e+12. What is the difference between the Imports (in Local Currency Unit) of Austria in 2007 and the Imports (in Local Currency Unit) of Trinidad and Tobago in 2010?
Offer a terse response. 9.25e+1. What is the difference between the Imports (in Local Currency Unit) of Estonia in 2007 and the Imports (in Local Currency Unit) of Philippines in 2010?
Make the answer very short. -3.29e+12. What is the difference between the Imports (in Local Currency Unit) of Estonia in 2007 and the Imports (in Local Currency Unit) of Trinidad and Tobago in 2010?
Your answer should be compact. -3.22e+1. What is the difference between the Imports (in Local Currency Unit) in Philippines in 2007 and the Imports (in Local Currency Unit) in Trinidad and Tobago in 2010?
Offer a terse response. 2.94e+12. What is the difference between the Imports (in Local Currency Unit) of Austria in 2008 and the Imports (in Local Currency Unit) of Estonia in 2009?
Your answer should be very brief. 1.35e+11. What is the difference between the Imports (in Local Currency Unit) in Austria in 2008 and the Imports (in Local Currency Unit) in Philippines in 2009?
Offer a very short reply. -2.53e+12. What is the difference between the Imports (in Local Currency Unit) in Austria in 2008 and the Imports (in Local Currency Unit) in Trinidad and Tobago in 2009?
Provide a succinct answer. 9.64e+1. What is the difference between the Imports (in Local Currency Unit) of Estonia in 2008 and the Imports (in Local Currency Unit) of Philippines in 2009?
Offer a very short reply. -2.67e+12. What is the difference between the Imports (in Local Currency Unit) in Estonia in 2008 and the Imports (in Local Currency Unit) in Trinidad and Tobago in 2009?
Provide a short and direct response. -3.49e+1. What is the difference between the Imports (in Local Currency Unit) in Philippines in 2008 and the Imports (in Local Currency Unit) in Trinidad and Tobago in 2009?
Provide a short and direct response. 2.99e+12. What is the difference between the Imports (in Local Currency Unit) in Austria in 2008 and the Imports (in Local Currency Unit) in Estonia in 2010?
Keep it short and to the point. 1.33e+11. What is the difference between the Imports (in Local Currency Unit) in Austria in 2008 and the Imports (in Local Currency Unit) in Philippines in 2010?
Keep it short and to the point. -3.15e+12. What is the difference between the Imports (in Local Currency Unit) of Austria in 2008 and the Imports (in Local Currency Unit) of Trinidad and Tobago in 2010?
Ensure brevity in your answer.  9.90e+1. What is the difference between the Imports (in Local Currency Unit) in Estonia in 2008 and the Imports (in Local Currency Unit) in Philippines in 2010?
Provide a succinct answer. -3.29e+12. What is the difference between the Imports (in Local Currency Unit) in Estonia in 2008 and the Imports (in Local Currency Unit) in Trinidad and Tobago in 2010?
Provide a succinct answer. -3.22e+1. What is the difference between the Imports (in Local Currency Unit) of Philippines in 2008 and the Imports (in Local Currency Unit) of Trinidad and Tobago in 2010?
Provide a succinct answer. 3.00e+12. What is the difference between the Imports (in Local Currency Unit) in Austria in 2009 and the Imports (in Local Currency Unit) in Estonia in 2010?
Provide a short and direct response. 1.10e+11. What is the difference between the Imports (in Local Currency Unit) in Austria in 2009 and the Imports (in Local Currency Unit) in Philippines in 2010?
Your answer should be compact. -3.18e+12. What is the difference between the Imports (in Local Currency Unit) in Austria in 2009 and the Imports (in Local Currency Unit) in Trinidad and Tobago in 2010?
Your answer should be compact. 7.60e+1. What is the difference between the Imports (in Local Currency Unit) of Estonia in 2009 and the Imports (in Local Currency Unit) of Philippines in 2010?
Provide a short and direct response. -3.29e+12. What is the difference between the Imports (in Local Currency Unit) of Estonia in 2009 and the Imports (in Local Currency Unit) of Trinidad and Tobago in 2010?
Offer a very short reply. -3.60e+1. What is the difference between the Imports (in Local Currency Unit) of Philippines in 2009 and the Imports (in Local Currency Unit) of Trinidad and Tobago in 2010?
Provide a short and direct response. 2.63e+12. What is the average Imports (in Local Currency Unit) in Austria per year?
Provide a short and direct response. 1.23e+11. What is the average Imports (in Local Currency Unit) of Estonia per year?
Your answer should be very brief. 8.98e+09. What is the average Imports (in Local Currency Unit) in Philippines per year?
Offer a very short reply. 2.90e+12. What is the average Imports (in Local Currency Unit) of Trinidad and Tobago per year?
Ensure brevity in your answer.  4.34e+1. In the year 2003, what is the difference between the Imports (in Local Currency Unit) of Austria and Imports (in Local Currency Unit) of Estonia?
Your response must be concise. 9.11e+1. In the year 2003, what is the difference between the Imports (in Local Currency Unit) of Austria and Imports (in Local Currency Unit) of Philippines?
Provide a short and direct response. -2.39e+12. In the year 2003, what is the difference between the Imports (in Local Currency Unit) of Austria and Imports (in Local Currency Unit) of Trinidad and Tobago?
Offer a terse response. 6.99e+1. In the year 2003, what is the difference between the Imports (in Local Currency Unit) in Estonia and Imports (in Local Currency Unit) in Philippines?
Offer a terse response. -2.48e+12. In the year 2003, what is the difference between the Imports (in Local Currency Unit) of Estonia and Imports (in Local Currency Unit) of Trinidad and Tobago?
Offer a very short reply. -2.12e+1. In the year 2003, what is the difference between the Imports (in Local Currency Unit) in Philippines and Imports (in Local Currency Unit) in Trinidad and Tobago?
Your response must be concise. 2.46e+12. In the year 2004, what is the difference between the Imports (in Local Currency Unit) in Austria and Imports (in Local Currency Unit) in Estonia?
Ensure brevity in your answer.  9.96e+1. In the year 2004, what is the difference between the Imports (in Local Currency Unit) in Austria and Imports (in Local Currency Unit) in Philippines?
Your response must be concise. -2.66e+12. In the year 2004, what is the difference between the Imports (in Local Currency Unit) in Austria and Imports (in Local Currency Unit) in Trinidad and Tobago?
Keep it short and to the point. 7.31e+1. In the year 2004, what is the difference between the Imports (in Local Currency Unit) in Estonia and Imports (in Local Currency Unit) in Philippines?
Ensure brevity in your answer.  -2.76e+12. In the year 2004, what is the difference between the Imports (in Local Currency Unit) of Estonia and Imports (in Local Currency Unit) of Trinidad and Tobago?
Your response must be concise. -2.64e+1. In the year 2004, what is the difference between the Imports (in Local Currency Unit) in Philippines and Imports (in Local Currency Unit) in Trinidad and Tobago?
Offer a very short reply. 2.74e+12. In the year 2005, what is the difference between the Imports (in Local Currency Unit) of Austria and Imports (in Local Currency Unit) of Estonia?
Give a very brief answer. 1.07e+11. In the year 2005, what is the difference between the Imports (in Local Currency Unit) of Austria and Imports (in Local Currency Unit) of Philippines?
Provide a succinct answer. -2.82e+12. In the year 2005, what is the difference between the Imports (in Local Currency Unit) of Austria and Imports (in Local Currency Unit) of Trinidad and Tobago?
Your answer should be very brief. 7.57e+1. In the year 2005, what is the difference between the Imports (in Local Currency Unit) in Estonia and Imports (in Local Currency Unit) in Philippines?
Your answer should be very brief. -2.93e+12. In the year 2005, what is the difference between the Imports (in Local Currency Unit) of Estonia and Imports (in Local Currency Unit) of Trinidad and Tobago?
Your answer should be compact. -3.15e+1. In the year 2005, what is the difference between the Imports (in Local Currency Unit) in Philippines and Imports (in Local Currency Unit) in Trinidad and Tobago?
Provide a short and direct response. 2.90e+12. In the year 2006, what is the difference between the Imports (in Local Currency Unit) of Austria and Imports (in Local Currency Unit) of Estonia?
Offer a terse response. 1.16e+11. In the year 2006, what is the difference between the Imports (in Local Currency Unit) in Austria and Imports (in Local Currency Unit) in Philippines?
Your answer should be very brief. -2.91e+12. In the year 2006, what is the difference between the Imports (in Local Currency Unit) in Austria and Imports (in Local Currency Unit) in Trinidad and Tobago?
Provide a short and direct response. 8.29e+1. In the year 2006, what is the difference between the Imports (in Local Currency Unit) in Estonia and Imports (in Local Currency Unit) in Philippines?
Provide a succinct answer. -3.02e+12. In the year 2006, what is the difference between the Imports (in Local Currency Unit) of Estonia and Imports (in Local Currency Unit) of Trinidad and Tobago?
Provide a succinct answer. -3.35e+1. In the year 2006, what is the difference between the Imports (in Local Currency Unit) of Philippines and Imports (in Local Currency Unit) of Trinidad and Tobago?
Offer a very short reply. 2.99e+12. In the year 2007, what is the difference between the Imports (in Local Currency Unit) in Austria and Imports (in Local Currency Unit) in Estonia?
Provide a succinct answer. 1.25e+11. In the year 2007, what is the difference between the Imports (in Local Currency Unit) in Austria and Imports (in Local Currency Unit) in Philippines?
Your answer should be very brief. -2.85e+12. In the year 2007, what is the difference between the Imports (in Local Currency Unit) in Austria and Imports (in Local Currency Unit) in Trinidad and Tobago?
Make the answer very short. 8.54e+1. In the year 2007, what is the difference between the Imports (in Local Currency Unit) of Estonia and Imports (in Local Currency Unit) of Philippines?
Provide a succinct answer. -2.98e+12. In the year 2007, what is the difference between the Imports (in Local Currency Unit) in Estonia and Imports (in Local Currency Unit) in Trinidad and Tobago?
Offer a very short reply. -3.93e+1. In the year 2007, what is the difference between the Imports (in Local Currency Unit) in Philippines and Imports (in Local Currency Unit) in Trinidad and Tobago?
Your response must be concise. 2.94e+12. In the year 2008, what is the difference between the Imports (in Local Currency Unit) of Austria and Imports (in Local Currency Unit) of Estonia?
Your answer should be very brief. 1.31e+11. In the year 2008, what is the difference between the Imports (in Local Currency Unit) of Austria and Imports (in Local Currency Unit) of Philippines?
Your response must be concise. -2.90e+12. In the year 2008, what is the difference between the Imports (in Local Currency Unit) of Austria and Imports (in Local Currency Unit) of Trinidad and Tobago?
Make the answer very short. 8.07e+1. In the year 2008, what is the difference between the Imports (in Local Currency Unit) in Estonia and Imports (in Local Currency Unit) in Philippines?
Keep it short and to the point. -3.03e+12. In the year 2008, what is the difference between the Imports (in Local Currency Unit) of Estonia and Imports (in Local Currency Unit) of Trinidad and Tobago?
Your answer should be very brief. -5.06e+1. In the year 2008, what is the difference between the Imports (in Local Currency Unit) in Philippines and Imports (in Local Currency Unit) in Trinidad and Tobago?
Offer a very short reply. 2.98e+12. In the year 2009, what is the difference between the Imports (in Local Currency Unit) of Austria and Imports (in Local Currency Unit) of Estonia?
Provide a short and direct response. 1.12e+11. In the year 2009, what is the difference between the Imports (in Local Currency Unit) of Austria and Imports (in Local Currency Unit) of Philippines?
Give a very brief answer. -2.56e+12. In the year 2009, what is the difference between the Imports (in Local Currency Unit) in Austria and Imports (in Local Currency Unit) in Trinidad and Tobago?
Keep it short and to the point. 7.34e+1. In the year 2009, what is the difference between the Imports (in Local Currency Unit) in Estonia and Imports (in Local Currency Unit) in Philippines?
Your answer should be very brief. -2.67e+12. In the year 2009, what is the difference between the Imports (in Local Currency Unit) of Estonia and Imports (in Local Currency Unit) of Trinidad and Tobago?
Make the answer very short. -3.87e+1. In the year 2009, what is the difference between the Imports (in Local Currency Unit) of Philippines and Imports (in Local Currency Unit) of Trinidad and Tobago?
Provide a succinct answer. 2.63e+12. In the year 2010, what is the difference between the Imports (in Local Currency Unit) of Austria and Imports (in Local Currency Unit) of Estonia?
Keep it short and to the point. 1.30e+11. In the year 2010, what is the difference between the Imports (in Local Currency Unit) in Austria and Imports (in Local Currency Unit) in Philippines?
Your response must be concise. -3.16e+12. In the year 2010, what is the difference between the Imports (in Local Currency Unit) of Austria and Imports (in Local Currency Unit) of Trinidad and Tobago?
Ensure brevity in your answer.  9.65e+1. In the year 2010, what is the difference between the Imports (in Local Currency Unit) of Estonia and Imports (in Local Currency Unit) of Philippines?
Provide a succinct answer. -3.29e+12. In the year 2010, what is the difference between the Imports (in Local Currency Unit) in Estonia and Imports (in Local Currency Unit) in Trinidad and Tobago?
Provide a short and direct response. -3.38e+1. In the year 2010, what is the difference between the Imports (in Local Currency Unit) in Philippines and Imports (in Local Currency Unit) in Trinidad and Tobago?
Give a very brief answer. 3.25e+12. What is the ratio of the Imports (in Local Currency Unit) in Austria in 2003 to that in 2004?
Your answer should be compact. 0.91. What is the ratio of the Imports (in Local Currency Unit) in Estonia in 2003 to that in 2004?
Provide a succinct answer. 0.85. What is the ratio of the Imports (in Local Currency Unit) of Philippines in 2003 to that in 2004?
Your response must be concise. 0.9. What is the ratio of the Imports (in Local Currency Unit) of Trinidad and Tobago in 2003 to that in 2004?
Provide a succinct answer. 0.81. What is the ratio of the Imports (in Local Currency Unit) of Austria in 2003 to that in 2005?
Your answer should be compact. 0.84. What is the ratio of the Imports (in Local Currency Unit) of Estonia in 2003 to that in 2005?
Ensure brevity in your answer.  0.72. What is the ratio of the Imports (in Local Currency Unit) in Philippines in 2003 to that in 2005?
Provide a succinct answer. 0.85. What is the ratio of the Imports (in Local Currency Unit) in Trinidad and Tobago in 2003 to that in 2005?
Offer a very short reply. 0.68. What is the ratio of the Imports (in Local Currency Unit) of Austria in 2003 to that in 2006?
Your answer should be compact. 0.77. What is the ratio of the Imports (in Local Currency Unit) in Estonia in 2003 to that in 2006?
Keep it short and to the point. 0.58. What is the ratio of the Imports (in Local Currency Unit) in Philippines in 2003 to that in 2006?
Offer a very short reply. 0.82. What is the ratio of the Imports (in Local Currency Unit) in Trinidad and Tobago in 2003 to that in 2006?
Give a very brief answer. 0.62. What is the ratio of the Imports (in Local Currency Unit) of Austria in 2003 to that in 2007?
Ensure brevity in your answer.  0.71. What is the ratio of the Imports (in Local Currency Unit) in Estonia in 2003 to that in 2007?
Give a very brief answer. 0.49. What is the ratio of the Imports (in Local Currency Unit) of Philippines in 2003 to that in 2007?
Offer a very short reply. 0.83. What is the ratio of the Imports (in Local Currency Unit) of Trinidad and Tobago in 2003 to that in 2007?
Keep it short and to the point. 0.53. What is the ratio of the Imports (in Local Currency Unit) in Austria in 2003 to that in 2008?
Your answer should be very brief. 0.68. What is the ratio of the Imports (in Local Currency Unit) in Estonia in 2003 to that in 2008?
Offer a very short reply. 0.49. What is the ratio of the Imports (in Local Currency Unit) in Philippines in 2003 to that in 2008?
Keep it short and to the point. 0.82. What is the ratio of the Imports (in Local Currency Unit) of Trinidad and Tobago in 2003 to that in 2008?
Your response must be concise. 0.43. What is the ratio of the Imports (in Local Currency Unit) in Austria in 2003 to that in 2009?
Keep it short and to the point. 0.81. What is the ratio of the Imports (in Local Currency Unit) in Estonia in 2003 to that in 2009?
Your answer should be very brief. 0.73. What is the ratio of the Imports (in Local Currency Unit) of Philippines in 2003 to that in 2009?
Your response must be concise. 0.93. What is the ratio of the Imports (in Local Currency Unit) in Trinidad and Tobago in 2003 to that in 2009?
Give a very brief answer. 0.58. What is the ratio of the Imports (in Local Currency Unit) of Austria in 2003 to that in 2010?
Your response must be concise. 0.69. What is the ratio of the Imports (in Local Currency Unit) in Estonia in 2003 to that in 2010?
Offer a terse response. 0.57. What is the ratio of the Imports (in Local Currency Unit) of Philippines in 2003 to that in 2010?
Provide a succinct answer. 0.75. What is the ratio of the Imports (in Local Currency Unit) in Trinidad and Tobago in 2003 to that in 2010?
Offer a terse response. 0.61. What is the ratio of the Imports (in Local Currency Unit) in Austria in 2004 to that in 2005?
Offer a terse response. 0.92. What is the ratio of the Imports (in Local Currency Unit) in Estonia in 2004 to that in 2005?
Make the answer very short. 0.84. What is the ratio of the Imports (in Local Currency Unit) of Philippines in 2004 to that in 2005?
Provide a succinct answer. 0.94. What is the ratio of the Imports (in Local Currency Unit) in Trinidad and Tobago in 2004 to that in 2005?
Keep it short and to the point. 0.84. What is the ratio of the Imports (in Local Currency Unit) of Austria in 2004 to that in 2006?
Provide a succinct answer. 0.84. What is the ratio of the Imports (in Local Currency Unit) of Estonia in 2004 to that in 2006?
Your answer should be compact. 0.68. What is the ratio of the Imports (in Local Currency Unit) of Philippines in 2004 to that in 2006?
Make the answer very short. 0.91. What is the ratio of the Imports (in Local Currency Unit) in Trinidad and Tobago in 2004 to that in 2006?
Your response must be concise. 0.76. What is the ratio of the Imports (in Local Currency Unit) in Austria in 2004 to that in 2007?
Keep it short and to the point. 0.78. What is the ratio of the Imports (in Local Currency Unit) of Estonia in 2004 to that in 2007?
Ensure brevity in your answer.  0.58. What is the ratio of the Imports (in Local Currency Unit) in Philippines in 2004 to that in 2007?
Offer a terse response. 0.93. What is the ratio of the Imports (in Local Currency Unit) of Trinidad and Tobago in 2004 to that in 2007?
Your answer should be very brief. 0.65. What is the ratio of the Imports (in Local Currency Unit) in Austria in 2004 to that in 2008?
Your answer should be very brief. 0.74. What is the ratio of the Imports (in Local Currency Unit) of Estonia in 2004 to that in 2008?
Keep it short and to the point. 0.58. What is the ratio of the Imports (in Local Currency Unit) in Philippines in 2004 to that in 2008?
Provide a succinct answer. 0.91. What is the ratio of the Imports (in Local Currency Unit) of Trinidad and Tobago in 2004 to that in 2008?
Your response must be concise. 0.53. What is the ratio of the Imports (in Local Currency Unit) of Austria in 2004 to that in 2009?
Give a very brief answer. 0.89. What is the ratio of the Imports (in Local Currency Unit) in Estonia in 2004 to that in 2009?
Provide a succinct answer. 0.85. What is the ratio of the Imports (in Local Currency Unit) of Philippines in 2004 to that in 2009?
Give a very brief answer. 1.03. What is the ratio of the Imports (in Local Currency Unit) in Trinidad and Tobago in 2004 to that in 2009?
Offer a terse response. 0.71. What is the ratio of the Imports (in Local Currency Unit) of Austria in 2004 to that in 2010?
Your answer should be compact. 0.76. What is the ratio of the Imports (in Local Currency Unit) of Estonia in 2004 to that in 2010?
Keep it short and to the point. 0.67. What is the ratio of the Imports (in Local Currency Unit) in Philippines in 2004 to that in 2010?
Offer a very short reply. 0.84. What is the ratio of the Imports (in Local Currency Unit) of Trinidad and Tobago in 2004 to that in 2010?
Your response must be concise. 0.76. What is the ratio of the Imports (in Local Currency Unit) of Austria in 2005 to that in 2006?
Provide a short and direct response. 0.91. What is the ratio of the Imports (in Local Currency Unit) of Estonia in 2005 to that in 2006?
Provide a short and direct response. 0.8. What is the ratio of the Imports (in Local Currency Unit) in Philippines in 2005 to that in 2006?
Keep it short and to the point. 0.97. What is the ratio of the Imports (in Local Currency Unit) of Trinidad and Tobago in 2005 to that in 2006?
Provide a short and direct response. 0.91. What is the ratio of the Imports (in Local Currency Unit) of Austria in 2005 to that in 2007?
Offer a very short reply. 0.84. What is the ratio of the Imports (in Local Currency Unit) of Estonia in 2005 to that in 2007?
Offer a terse response. 0.68. What is the ratio of the Imports (in Local Currency Unit) of Philippines in 2005 to that in 2007?
Ensure brevity in your answer.  0.98. What is the ratio of the Imports (in Local Currency Unit) in Trinidad and Tobago in 2005 to that in 2007?
Make the answer very short. 0.77. What is the ratio of the Imports (in Local Currency Unit) in Austria in 2005 to that in 2008?
Give a very brief answer. 0.81. What is the ratio of the Imports (in Local Currency Unit) in Estonia in 2005 to that in 2008?
Provide a succinct answer. 0.68. What is the ratio of the Imports (in Local Currency Unit) in Philippines in 2005 to that in 2008?
Ensure brevity in your answer.  0.97. What is the ratio of the Imports (in Local Currency Unit) in Trinidad and Tobago in 2005 to that in 2008?
Offer a very short reply. 0.63. What is the ratio of the Imports (in Local Currency Unit) of Austria in 2005 to that in 2009?
Offer a very short reply. 0.96. What is the ratio of the Imports (in Local Currency Unit) of Estonia in 2005 to that in 2009?
Provide a short and direct response. 1.01. What is the ratio of the Imports (in Local Currency Unit) of Philippines in 2005 to that in 2009?
Give a very brief answer. 1.1. What is the ratio of the Imports (in Local Currency Unit) of Trinidad and Tobago in 2005 to that in 2009?
Your response must be concise. 0.85. What is the ratio of the Imports (in Local Currency Unit) of Austria in 2005 to that in 2010?
Provide a short and direct response. 0.82. What is the ratio of the Imports (in Local Currency Unit) of Estonia in 2005 to that in 2010?
Your answer should be compact. 0.79. What is the ratio of the Imports (in Local Currency Unit) in Philippines in 2005 to that in 2010?
Offer a terse response. 0.89. What is the ratio of the Imports (in Local Currency Unit) of Trinidad and Tobago in 2005 to that in 2010?
Keep it short and to the point. 0.9. What is the ratio of the Imports (in Local Currency Unit) of Austria in 2006 to that in 2007?
Provide a succinct answer. 0.93. What is the ratio of the Imports (in Local Currency Unit) of Estonia in 2006 to that in 2007?
Give a very brief answer. 0.85. What is the ratio of the Imports (in Local Currency Unit) of Philippines in 2006 to that in 2007?
Offer a very short reply. 1.01. What is the ratio of the Imports (in Local Currency Unit) in Trinidad and Tobago in 2006 to that in 2007?
Your answer should be very brief. 0.85. What is the ratio of the Imports (in Local Currency Unit) of Austria in 2006 to that in 2008?
Your response must be concise. 0.88. What is the ratio of the Imports (in Local Currency Unit) of Estonia in 2006 to that in 2008?
Your response must be concise. 0.85. What is the ratio of the Imports (in Local Currency Unit) of Trinidad and Tobago in 2006 to that in 2008?
Your response must be concise. 0.7. What is the ratio of the Imports (in Local Currency Unit) of Austria in 2006 to that in 2009?
Make the answer very short. 1.05. What is the ratio of the Imports (in Local Currency Unit) of Estonia in 2006 to that in 2009?
Your response must be concise. 1.26. What is the ratio of the Imports (in Local Currency Unit) in Philippines in 2006 to that in 2009?
Keep it short and to the point. 1.13. What is the ratio of the Imports (in Local Currency Unit) of Trinidad and Tobago in 2006 to that in 2009?
Keep it short and to the point. 0.93. What is the ratio of the Imports (in Local Currency Unit) in Austria in 2006 to that in 2010?
Offer a terse response. 0.9. What is the ratio of the Imports (in Local Currency Unit) of Estonia in 2006 to that in 2010?
Give a very brief answer. 0.98. What is the ratio of the Imports (in Local Currency Unit) in Austria in 2007 to that in 2008?
Ensure brevity in your answer.  0.95. What is the ratio of the Imports (in Local Currency Unit) in Estonia in 2007 to that in 2008?
Make the answer very short. 1. What is the ratio of the Imports (in Local Currency Unit) in Philippines in 2007 to that in 2008?
Your answer should be very brief. 0.98. What is the ratio of the Imports (in Local Currency Unit) in Trinidad and Tobago in 2007 to that in 2008?
Your answer should be compact. 0.82. What is the ratio of the Imports (in Local Currency Unit) of Austria in 2007 to that in 2009?
Your response must be concise. 1.14. What is the ratio of the Imports (in Local Currency Unit) in Estonia in 2007 to that in 2009?
Offer a very short reply. 1.48. What is the ratio of the Imports (in Local Currency Unit) of Philippines in 2007 to that in 2009?
Offer a terse response. 1.12. What is the ratio of the Imports (in Local Currency Unit) of Trinidad and Tobago in 2007 to that in 2009?
Offer a terse response. 1.1. What is the ratio of the Imports (in Local Currency Unit) in Austria in 2007 to that in 2010?
Your response must be concise. 0.97. What is the ratio of the Imports (in Local Currency Unit) in Estonia in 2007 to that in 2010?
Provide a short and direct response. 1.16. What is the ratio of the Imports (in Local Currency Unit) in Philippines in 2007 to that in 2010?
Offer a terse response. 0.91. What is the ratio of the Imports (in Local Currency Unit) of Trinidad and Tobago in 2007 to that in 2010?
Make the answer very short. 1.16. What is the ratio of the Imports (in Local Currency Unit) of Austria in 2008 to that in 2009?
Your answer should be compact. 1.19. What is the ratio of the Imports (in Local Currency Unit) of Estonia in 2008 to that in 2009?
Ensure brevity in your answer.  1.48. What is the ratio of the Imports (in Local Currency Unit) of Philippines in 2008 to that in 2009?
Give a very brief answer. 1.14. What is the ratio of the Imports (in Local Currency Unit) in Trinidad and Tobago in 2008 to that in 2009?
Ensure brevity in your answer.  1.34. What is the ratio of the Imports (in Local Currency Unit) in Austria in 2008 to that in 2010?
Your answer should be very brief. 1.02. What is the ratio of the Imports (in Local Currency Unit) of Estonia in 2008 to that in 2010?
Provide a short and direct response. 1.16. What is the ratio of the Imports (in Local Currency Unit) of Philippines in 2008 to that in 2010?
Keep it short and to the point. 0.92. What is the ratio of the Imports (in Local Currency Unit) of Trinidad and Tobago in 2008 to that in 2010?
Provide a short and direct response. 1.42. What is the ratio of the Imports (in Local Currency Unit) in Austria in 2009 to that in 2010?
Offer a terse response. 0.85. What is the ratio of the Imports (in Local Currency Unit) of Estonia in 2009 to that in 2010?
Offer a very short reply. 0.78. What is the ratio of the Imports (in Local Currency Unit) of Philippines in 2009 to that in 2010?
Make the answer very short. 0.81. What is the ratio of the Imports (in Local Currency Unit) of Trinidad and Tobago in 2009 to that in 2010?
Your answer should be very brief. 1.06. What is the difference between the highest and the second highest Imports (in Local Currency Unit) of Austria?
Ensure brevity in your answer.  2.48e+09. What is the difference between the highest and the second highest Imports (in Local Currency Unit) in Estonia?
Give a very brief answer. 2.69e+07. What is the difference between the highest and the second highest Imports (in Local Currency Unit) of Philippines?
Keep it short and to the point. 2.57e+11. What is the difference between the highest and the second highest Imports (in Local Currency Unit) in Trinidad and Tobago?
Offer a terse response. 1.13e+1. What is the difference between the highest and the lowest Imports (in Local Currency Unit) in Austria?
Provide a succinct answer. 4.61e+1. What is the difference between the highest and the lowest Imports (in Local Currency Unit) in Estonia?
Your answer should be compact. 5.97e+09. What is the difference between the highest and the lowest Imports (in Local Currency Unit) of Philippines?
Your answer should be compact. 8.09e+11. What is the difference between the highest and the lowest Imports (in Local Currency Unit) in Trinidad and Tobago?
Offer a very short reply. 3.53e+1. 